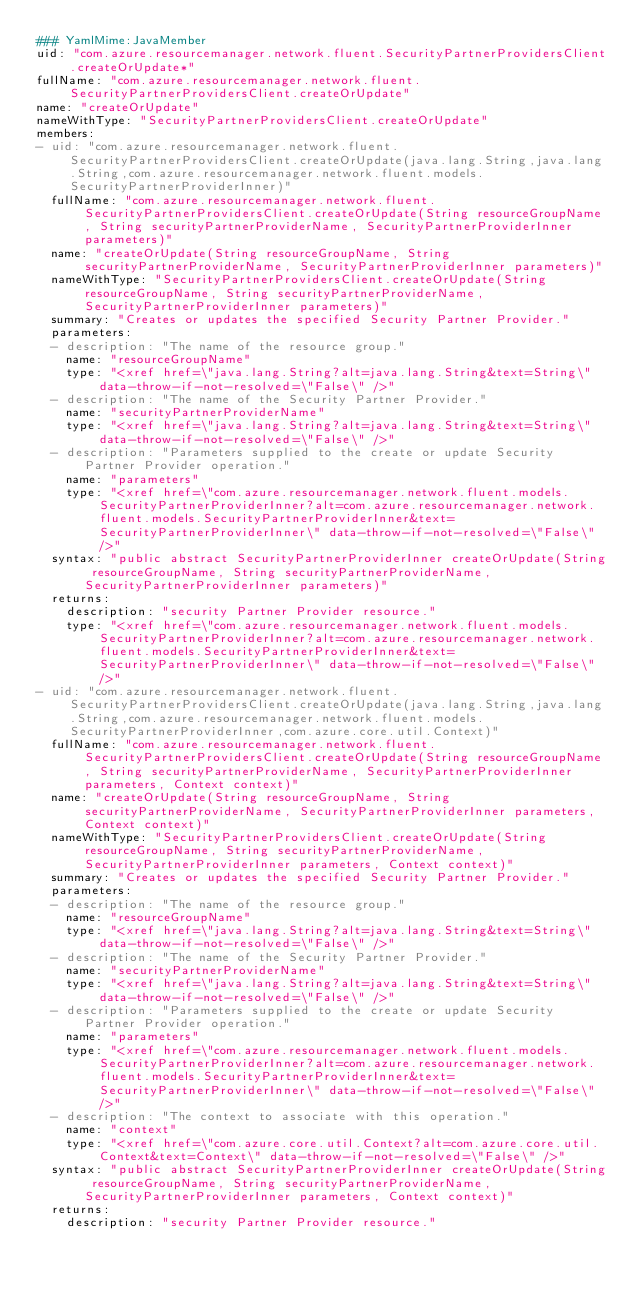<code> <loc_0><loc_0><loc_500><loc_500><_YAML_>### YamlMime:JavaMember
uid: "com.azure.resourcemanager.network.fluent.SecurityPartnerProvidersClient.createOrUpdate*"
fullName: "com.azure.resourcemanager.network.fluent.SecurityPartnerProvidersClient.createOrUpdate"
name: "createOrUpdate"
nameWithType: "SecurityPartnerProvidersClient.createOrUpdate"
members:
- uid: "com.azure.resourcemanager.network.fluent.SecurityPartnerProvidersClient.createOrUpdate(java.lang.String,java.lang.String,com.azure.resourcemanager.network.fluent.models.SecurityPartnerProviderInner)"
  fullName: "com.azure.resourcemanager.network.fluent.SecurityPartnerProvidersClient.createOrUpdate(String resourceGroupName, String securityPartnerProviderName, SecurityPartnerProviderInner parameters)"
  name: "createOrUpdate(String resourceGroupName, String securityPartnerProviderName, SecurityPartnerProviderInner parameters)"
  nameWithType: "SecurityPartnerProvidersClient.createOrUpdate(String resourceGroupName, String securityPartnerProviderName, SecurityPartnerProviderInner parameters)"
  summary: "Creates or updates the specified Security Partner Provider."
  parameters:
  - description: "The name of the resource group."
    name: "resourceGroupName"
    type: "<xref href=\"java.lang.String?alt=java.lang.String&text=String\" data-throw-if-not-resolved=\"False\" />"
  - description: "The name of the Security Partner Provider."
    name: "securityPartnerProviderName"
    type: "<xref href=\"java.lang.String?alt=java.lang.String&text=String\" data-throw-if-not-resolved=\"False\" />"
  - description: "Parameters supplied to the create or update Security Partner Provider operation."
    name: "parameters"
    type: "<xref href=\"com.azure.resourcemanager.network.fluent.models.SecurityPartnerProviderInner?alt=com.azure.resourcemanager.network.fluent.models.SecurityPartnerProviderInner&text=SecurityPartnerProviderInner\" data-throw-if-not-resolved=\"False\" />"
  syntax: "public abstract SecurityPartnerProviderInner createOrUpdate(String resourceGroupName, String securityPartnerProviderName, SecurityPartnerProviderInner parameters)"
  returns:
    description: "security Partner Provider resource."
    type: "<xref href=\"com.azure.resourcemanager.network.fluent.models.SecurityPartnerProviderInner?alt=com.azure.resourcemanager.network.fluent.models.SecurityPartnerProviderInner&text=SecurityPartnerProviderInner\" data-throw-if-not-resolved=\"False\" />"
- uid: "com.azure.resourcemanager.network.fluent.SecurityPartnerProvidersClient.createOrUpdate(java.lang.String,java.lang.String,com.azure.resourcemanager.network.fluent.models.SecurityPartnerProviderInner,com.azure.core.util.Context)"
  fullName: "com.azure.resourcemanager.network.fluent.SecurityPartnerProvidersClient.createOrUpdate(String resourceGroupName, String securityPartnerProviderName, SecurityPartnerProviderInner parameters, Context context)"
  name: "createOrUpdate(String resourceGroupName, String securityPartnerProviderName, SecurityPartnerProviderInner parameters, Context context)"
  nameWithType: "SecurityPartnerProvidersClient.createOrUpdate(String resourceGroupName, String securityPartnerProviderName, SecurityPartnerProviderInner parameters, Context context)"
  summary: "Creates or updates the specified Security Partner Provider."
  parameters:
  - description: "The name of the resource group."
    name: "resourceGroupName"
    type: "<xref href=\"java.lang.String?alt=java.lang.String&text=String\" data-throw-if-not-resolved=\"False\" />"
  - description: "The name of the Security Partner Provider."
    name: "securityPartnerProviderName"
    type: "<xref href=\"java.lang.String?alt=java.lang.String&text=String\" data-throw-if-not-resolved=\"False\" />"
  - description: "Parameters supplied to the create or update Security Partner Provider operation."
    name: "parameters"
    type: "<xref href=\"com.azure.resourcemanager.network.fluent.models.SecurityPartnerProviderInner?alt=com.azure.resourcemanager.network.fluent.models.SecurityPartnerProviderInner&text=SecurityPartnerProviderInner\" data-throw-if-not-resolved=\"False\" />"
  - description: "The context to associate with this operation."
    name: "context"
    type: "<xref href=\"com.azure.core.util.Context?alt=com.azure.core.util.Context&text=Context\" data-throw-if-not-resolved=\"False\" />"
  syntax: "public abstract SecurityPartnerProviderInner createOrUpdate(String resourceGroupName, String securityPartnerProviderName, SecurityPartnerProviderInner parameters, Context context)"
  returns:
    description: "security Partner Provider resource."</code> 